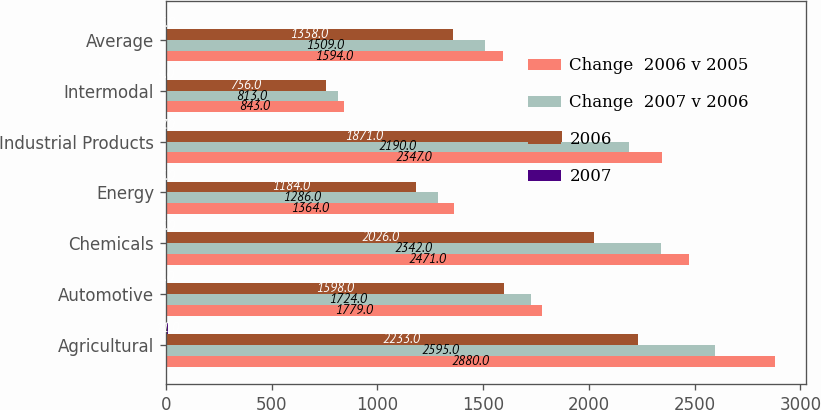Convert chart. <chart><loc_0><loc_0><loc_500><loc_500><stacked_bar_chart><ecel><fcel>Agricultural<fcel>Automotive<fcel>Chemicals<fcel>Energy<fcel>Industrial Products<fcel>Intermodal<fcel>Average<nl><fcel>Change  2006 v 2005<fcel>2880<fcel>1779<fcel>2471<fcel>1364<fcel>2347<fcel>843<fcel>1594<nl><fcel>Change  2007 v 2006<fcel>2595<fcel>1724<fcel>2342<fcel>1286<fcel>2190<fcel>813<fcel>1509<nl><fcel>2006<fcel>2233<fcel>1598<fcel>2026<fcel>1184<fcel>1871<fcel>756<fcel>1358<nl><fcel>2007<fcel>11<fcel>3<fcel>6<fcel>6<fcel>7<fcel>4<fcel>6<nl></chart> 